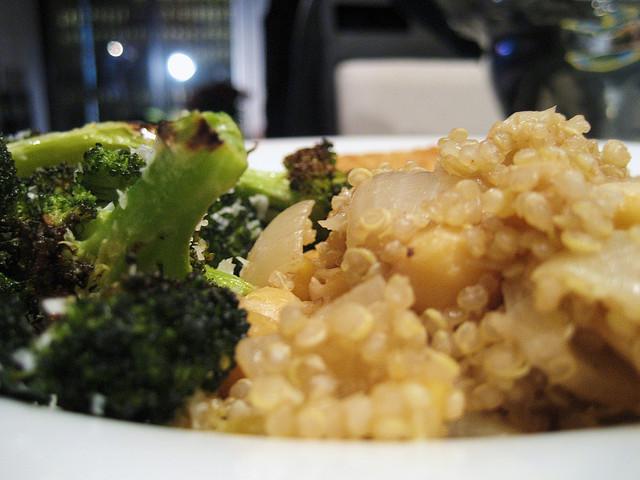What type of sauce is shown?
Short answer required. Cheese. Who made this dish?
Be succinct. Chef. What is the silver object?
Concise answer only. Plate. What is the main color do you see?
Give a very brief answer. Yellow. What color is the rice?
Be succinct. Brown. What vegetable is on the left?
Give a very brief answer. Broccoli. What makes the broccoli appear as though it was roasted?
Keep it brief. Steam. 